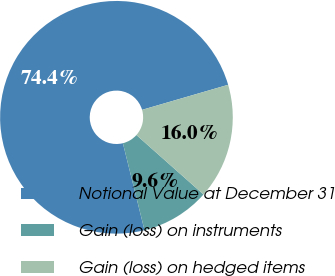Convert chart. <chart><loc_0><loc_0><loc_500><loc_500><pie_chart><fcel>Notional Value at December 31<fcel>Gain (loss) on instruments<fcel>Gain (loss) on hedged items<nl><fcel>74.37%<fcel>9.58%<fcel>16.05%<nl></chart> 